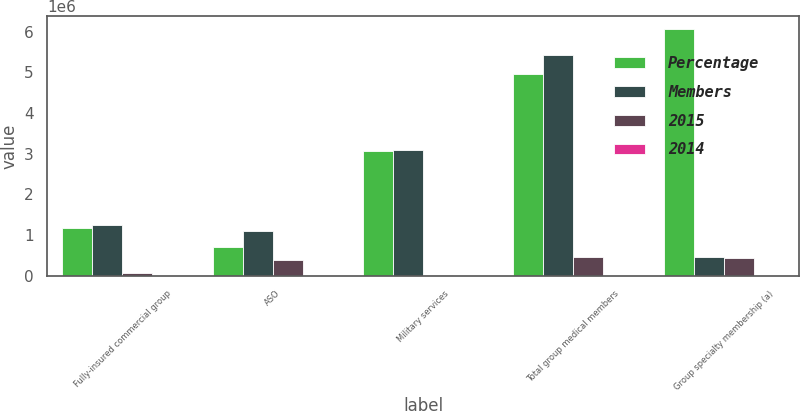Convert chart to OTSL. <chart><loc_0><loc_0><loc_500><loc_500><stacked_bar_chart><ecel><fcel>Fully-insured commercial group<fcel>ASO<fcel>Military services<fcel>Total group medical members<fcel>Group specialty membership (a)<nl><fcel>Percentage<fcel>1.1783e+06<fcel>710700<fcel>3.0744e+06<fcel>4.9634e+06<fcel>6.0687e+06<nl><fcel>Members<fcel>1.2355e+06<fcel>1.1043e+06<fcel>3.0904e+06<fcel>5.4302e+06<fcel>466800<nl><fcel>2015<fcel>57200<fcel>393600<fcel>16000<fcel>466800<fcel>434000<nl><fcel>2014<fcel>4.6<fcel>35.6<fcel>0.5<fcel>8.6<fcel>6.7<nl></chart> 